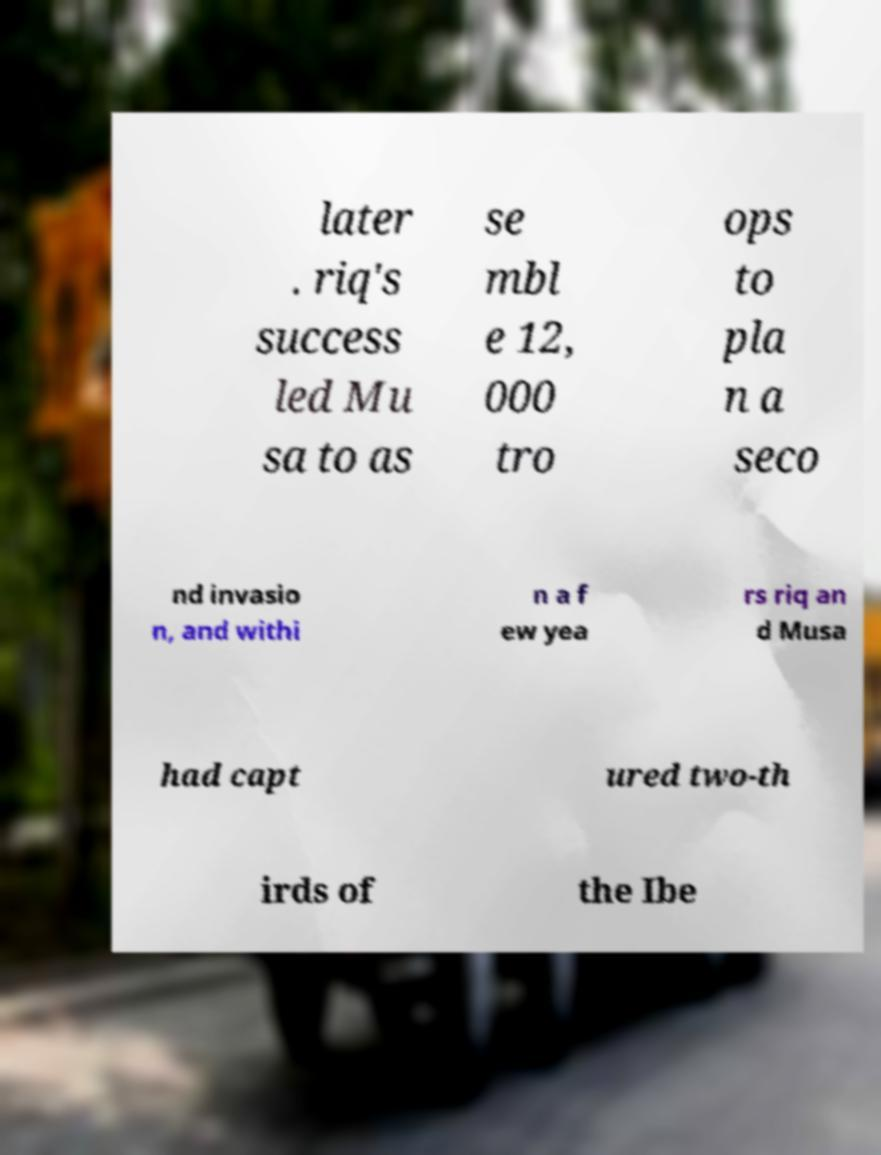Please read and relay the text visible in this image. What does it say? later . riq's success led Mu sa to as se mbl e 12, 000 tro ops to pla n a seco nd invasio n, and withi n a f ew yea rs riq an d Musa had capt ured two-th irds of the Ibe 